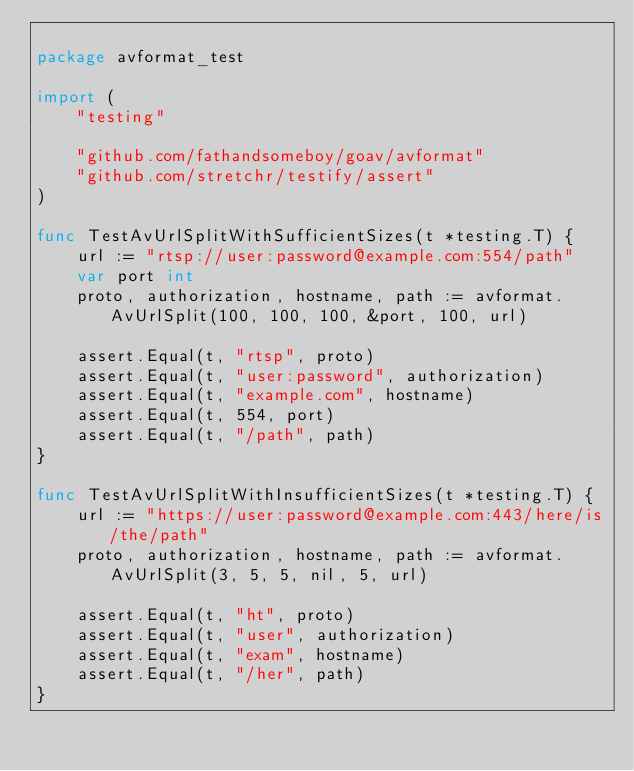Convert code to text. <code><loc_0><loc_0><loc_500><loc_500><_Go_>
package avformat_test

import (
	"testing"

	"github.com/fathandsomeboy/goav/avformat"
	"github.com/stretchr/testify/assert"
)

func TestAvUrlSplitWithSufficientSizes(t *testing.T) {
	url := "rtsp://user:password@example.com:554/path"
	var port int
	proto, authorization, hostname, path := avformat.AvUrlSplit(100, 100, 100, &port, 100, url)

	assert.Equal(t, "rtsp", proto)
	assert.Equal(t, "user:password", authorization)
	assert.Equal(t, "example.com", hostname)
	assert.Equal(t, 554, port)
	assert.Equal(t, "/path", path)
}

func TestAvUrlSplitWithInsufficientSizes(t *testing.T) {
	url := "https://user:password@example.com:443/here/is/the/path"
	proto, authorization, hostname, path := avformat.AvUrlSplit(3, 5, 5, nil, 5, url)

	assert.Equal(t, "ht", proto)
	assert.Equal(t, "user", authorization)
	assert.Equal(t, "exam", hostname)
	assert.Equal(t, "/her", path)
}
</code> 